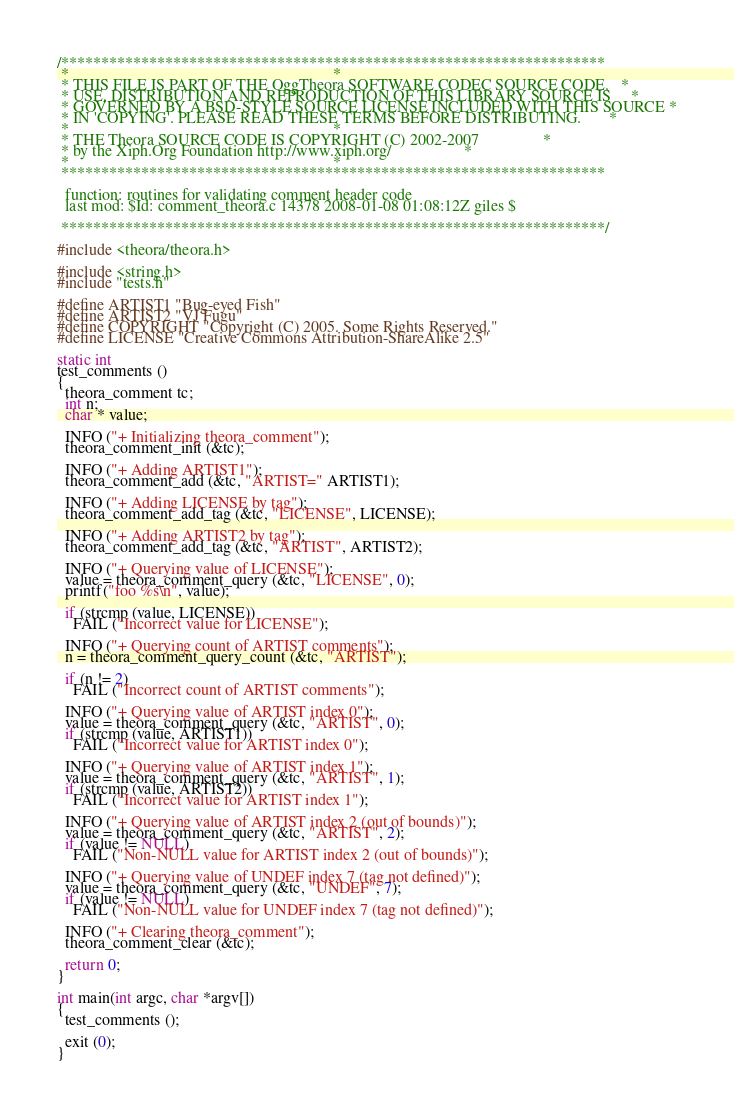<code> <loc_0><loc_0><loc_500><loc_500><_C_>/********************************************************************
 *                                                                  *
 * THIS FILE IS PART OF THE OggTheora SOFTWARE CODEC SOURCE CODE.   *
 * USE, DISTRIBUTION AND REPRODUCTION OF THIS LIBRARY SOURCE IS     *
 * GOVERNED BY A BSD-STYLE SOURCE LICENSE INCLUDED WITH THIS SOURCE *
 * IN 'COPYING'. PLEASE READ THESE TERMS BEFORE DISTRIBUTING.       *
 *                                                                  *
 * THE Theora SOURCE CODE IS COPYRIGHT (C) 2002-2007                *
 * by the Xiph.Org Foundation http://www.xiph.org/                  *
 *                                                                  *
 ********************************************************************

  function: routines for validating comment header code
  last mod: $Id: comment_theora.c 14378 2008-01-08 01:08:12Z giles $

 ********************************************************************/

#include <theora/theora.h>

#include <string.h>
#include "tests.h"

#define ARTIST1 "Bug-eyed Fish"
#define ARTIST2 "VJ Fugu"
#define COPYRIGHT "Copyright (C) 2005. Some Rights Reserved."
#define LICENSE "Creative Commons Attribution-ShareAlike 2.5"

static int
test_comments ()
{
  theora_comment tc;
  int n;
  char * value;

  INFO ("+ Initializing theora_comment");
  theora_comment_init (&tc);

  INFO ("+ Adding ARTIST1");
  theora_comment_add (&tc, "ARTIST=" ARTIST1);

  INFO ("+ Adding LICENSE by tag");
  theora_comment_add_tag (&tc, "LICENSE", LICENSE);

  INFO ("+ Adding ARTIST2 by tag");
  theora_comment_add_tag (&tc, "ARTIST", ARTIST2);

  INFO ("+ Querying value of LICENSE");
  value = theora_comment_query (&tc, "LICENSE", 0);
  printf("foo %s\n", value);

  if (strcmp (value, LICENSE))
    FAIL ("Incorrect value for LICENSE");

  INFO ("+ Querying count of ARTIST comments");
  n = theora_comment_query_count (&tc, "ARTIST");

  if (n != 2)
    FAIL ("Incorrect count of ARTIST comments");

  INFO ("+ Querying value of ARTIST index 0");
  value = theora_comment_query (&tc, "ARTIST", 0);
  if (strcmp (value, ARTIST1))
    FAIL ("Incorrect value for ARTIST index 0");

  INFO ("+ Querying value of ARTIST index 1");
  value = theora_comment_query (&tc, "ARTIST", 1);
  if (strcmp (value, ARTIST2))
    FAIL ("Incorrect value for ARTIST index 1");

  INFO ("+ Querying value of ARTIST index 2 (out of bounds)");
  value = theora_comment_query (&tc, "ARTIST", 2);
  if (value != NULL)
    FAIL ("Non-NULL value for ARTIST index 2 (out of bounds)");

  INFO ("+ Querying value of UNDEF index 7 (tag not defined)");
  value = theora_comment_query (&tc, "UNDEF", 7);
  if (value != NULL)
    FAIL ("Non-NULL value for UNDEF index 7 (tag not defined)");

  INFO ("+ Clearing theora_comment");
  theora_comment_clear (&tc);

  return 0;
}

int main(int argc, char *argv[])
{
  test_comments ();

  exit (0);
}
</code> 